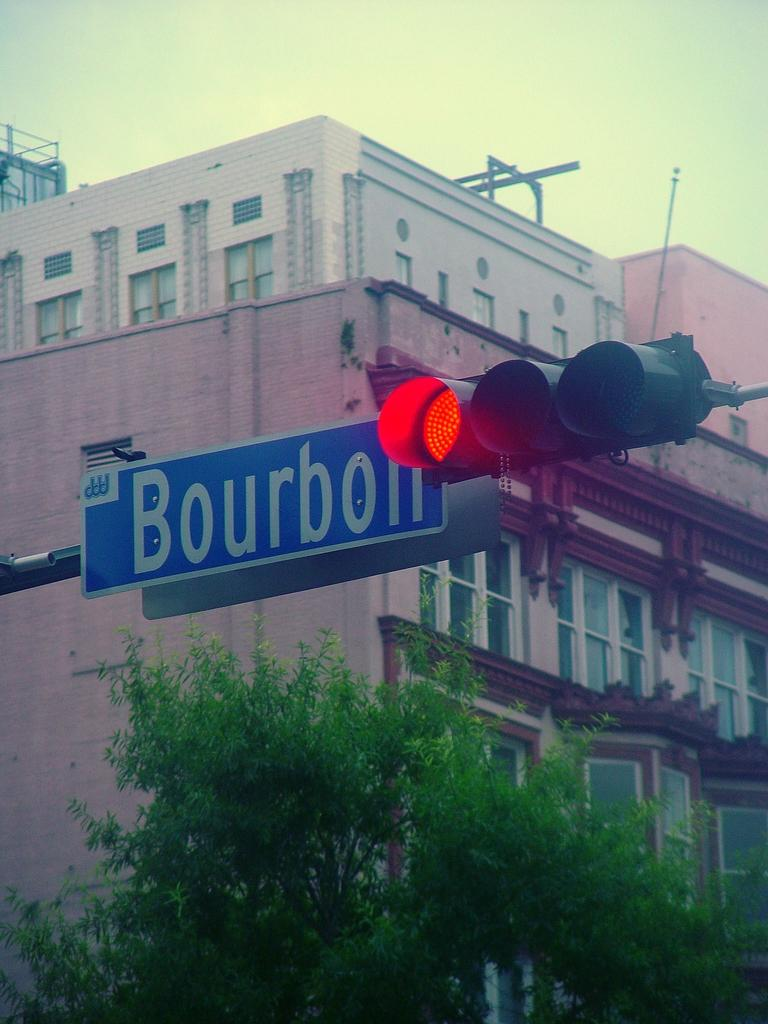Provide a one-sentence caption for the provided image. A traffic signal showing a red light is next to a blue street sign that says Bourbon. 